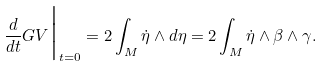Convert formula to latex. <formula><loc_0><loc_0><loc_500><loc_500>\frac { d } { d t } G V \Big | _ { t = 0 } = 2 \int _ { M } \dot { \eta } \wedge d \eta = 2 \int _ { M } \dot { \eta } \wedge \beta \wedge \gamma .</formula> 